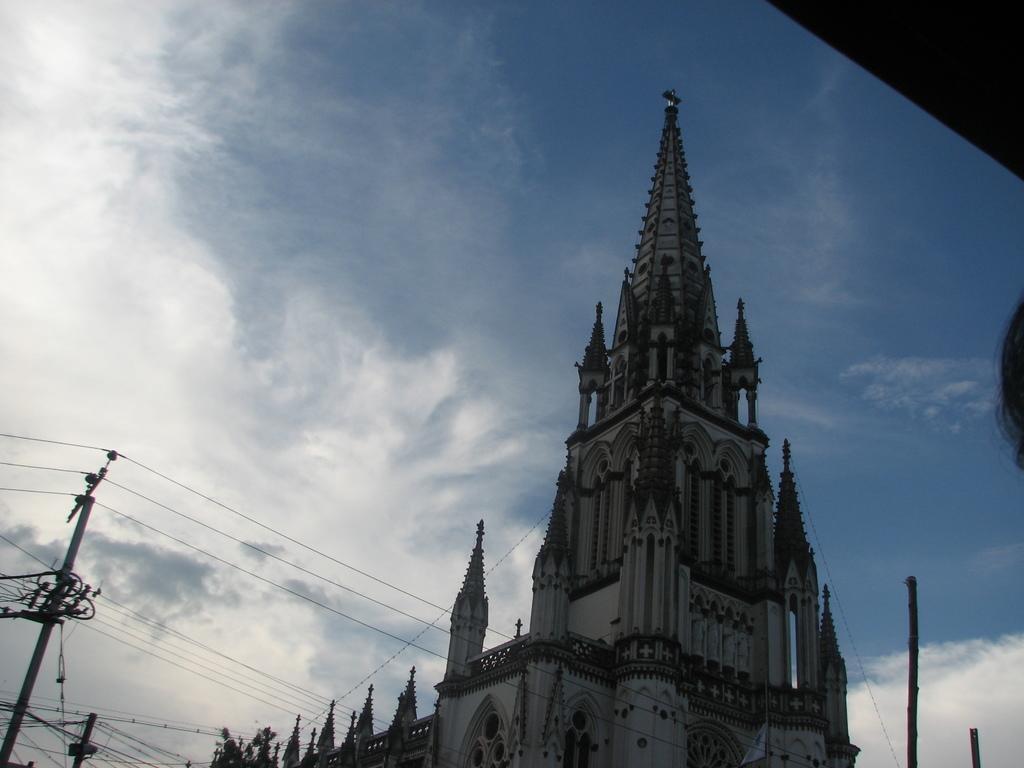How would you summarize this image in a sentence or two? In this image I can see the building. To the left I can see the current pole. In the background I can see the clouds and the sky. 